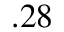Convert formula to latex. <formula><loc_0><loc_0><loc_500><loc_500>. 2 8</formula> 